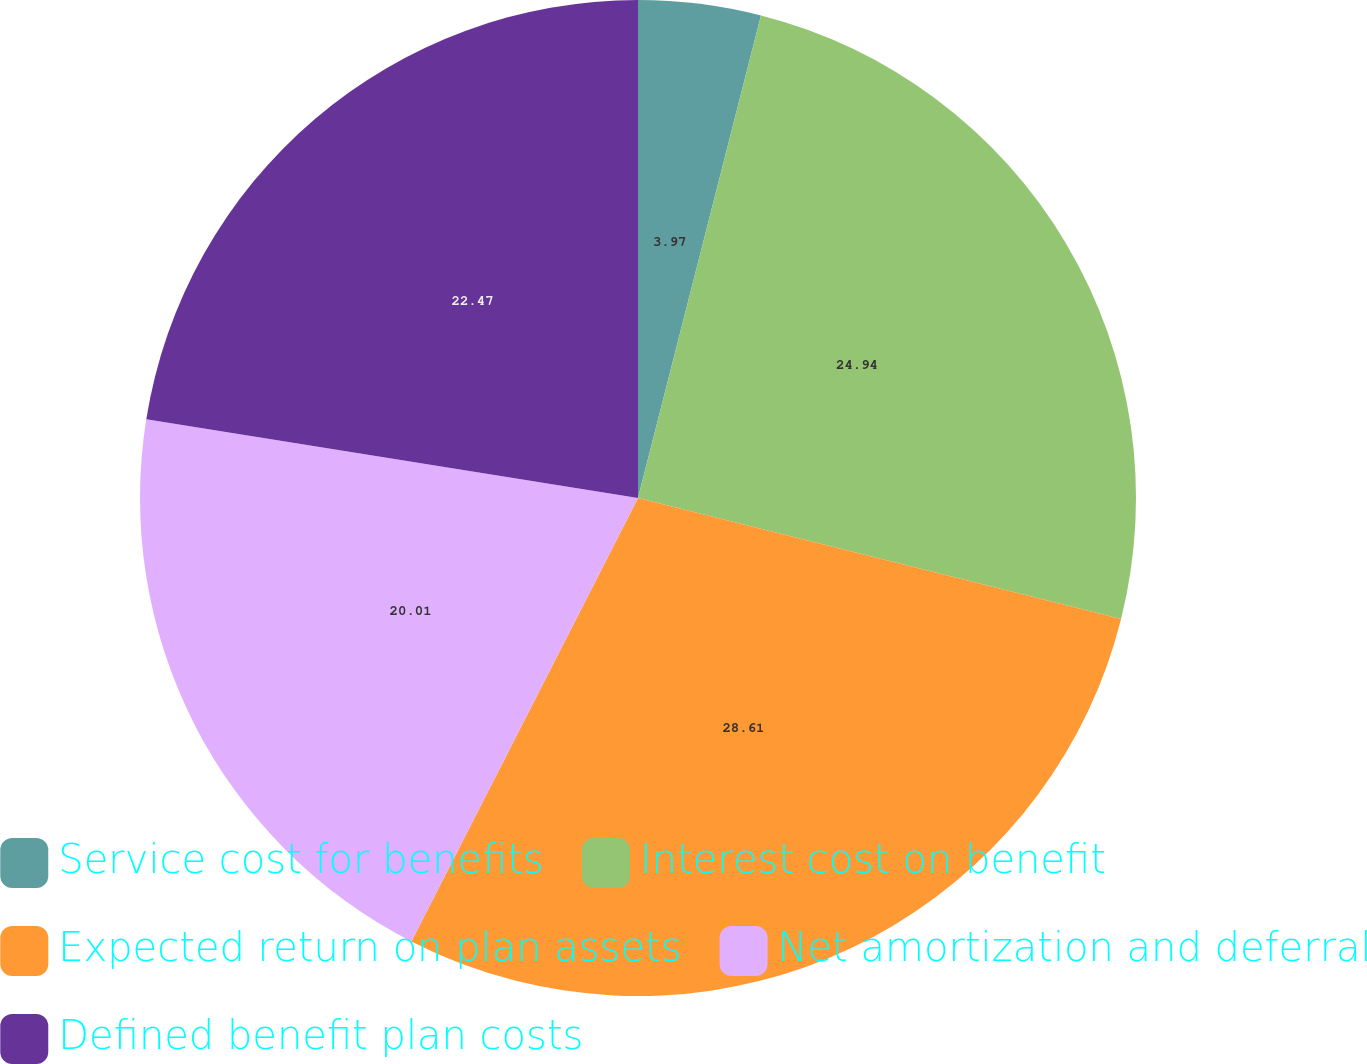Convert chart to OTSL. <chart><loc_0><loc_0><loc_500><loc_500><pie_chart><fcel>Service cost for benefits<fcel>Interest cost on benefit<fcel>Expected return on plan assets<fcel>Net amortization and deferral<fcel>Defined benefit plan costs<nl><fcel>3.97%<fcel>24.94%<fcel>28.61%<fcel>20.01%<fcel>22.47%<nl></chart> 